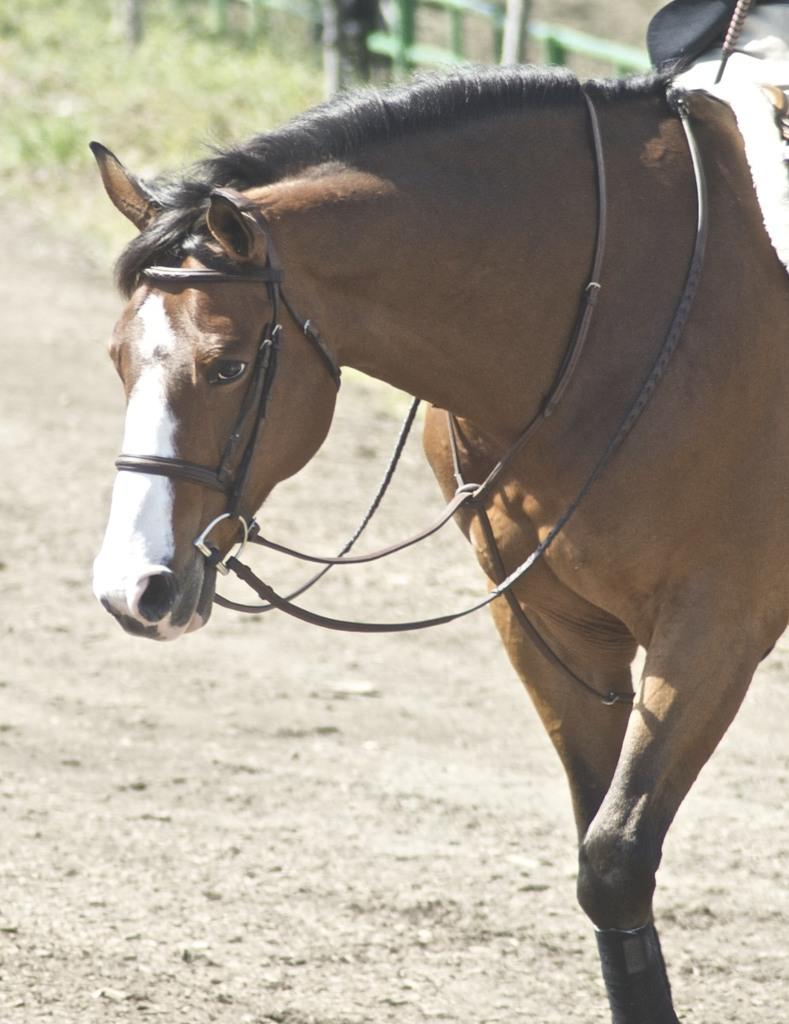What animal is present in the image? There is a horse standing in the image. What is attached to the horse's head? The horse has a nose band attached to it. What can be seen in the background of the image? There is a fence visible in the background of the image. What type of nut is being used to fix the horse's shoe in the image? There is no indication in the image that the horse's shoe is being fixed, nor is there any mention of a nut. 